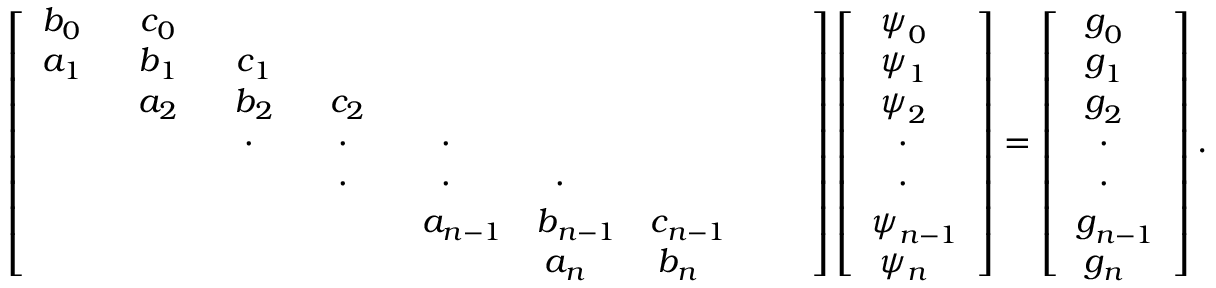Convert formula to latex. <formula><loc_0><loc_0><loc_500><loc_500>\left [ \begin{array} { c c c c c c c c c } { b _ { 0 } } & { c _ { 0 } } & & & & & & & \\ { a _ { 1 } } & { b _ { 1 } } & { c _ { 1 } } & & & & & & \\ & { a _ { 2 } } & { b _ { 2 } } & { c _ { 2 } } & & & & & \\ & & { } & { } & { } & & & & \\ & & & { } & { } & { } & & & \\ & & & & { a _ { n - 1 } } & { b _ { n - 1 } } & { c _ { n - 1 } } & & \\ & & & & & { a _ { n } } & { b _ { n } } \end{array} \right ] \left [ { \begin{array} { c } { \psi _ { 0 } } \\ { \psi _ { 1 } } \\ { \psi _ { 2 } } \\ { \cdot } \\ { \cdot } \\ { \psi _ { n - 1 } } \\ { \psi _ { n } } \end{array} } \right ] = \left [ { \begin{array} { c } { g _ { 0 } } \\ { g _ { 1 } } \\ { g _ { 2 } } \\ { \cdot } \\ { \cdot } \\ { g _ { n - 1 } } \\ { g _ { n } } \end{array} } \right ] .</formula> 